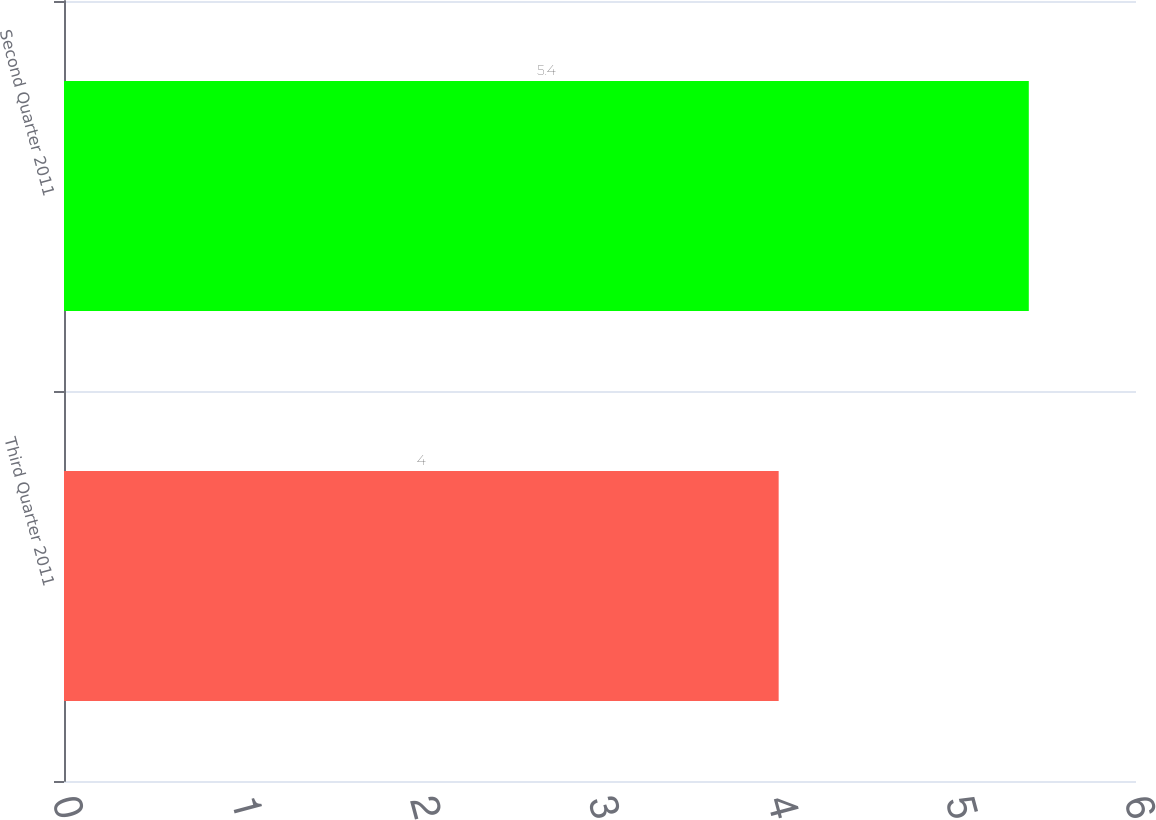Convert chart. <chart><loc_0><loc_0><loc_500><loc_500><bar_chart><fcel>Third Quarter 2011<fcel>Second Quarter 2011<nl><fcel>4<fcel>5.4<nl></chart> 